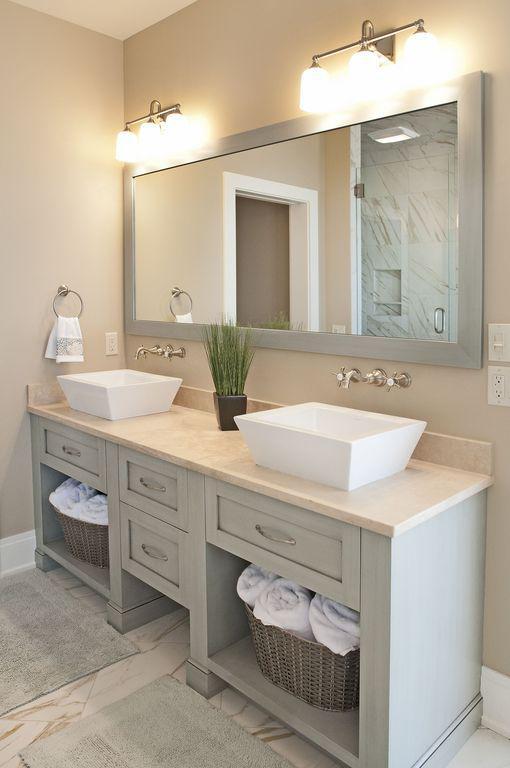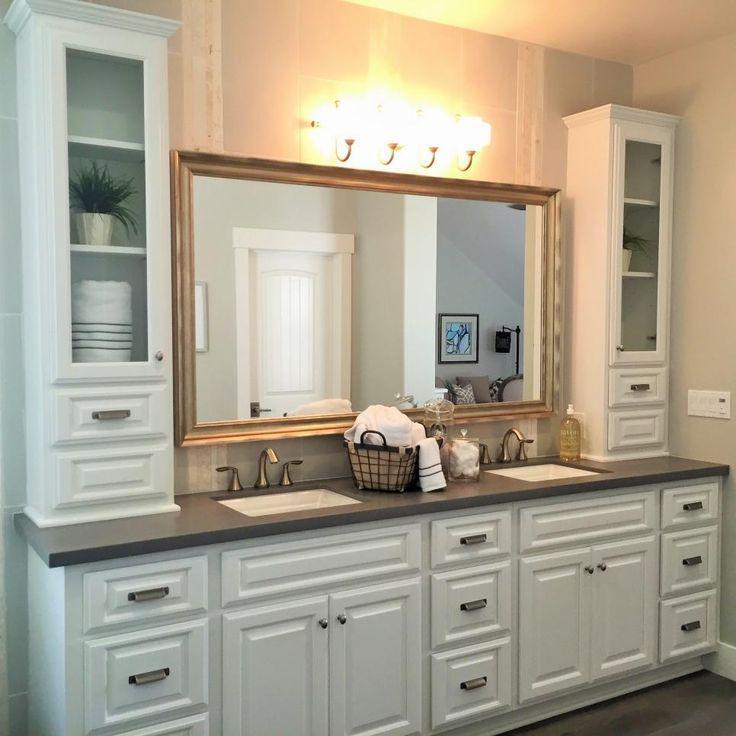The first image is the image on the left, the second image is the image on the right. Examine the images to the left and right. Is the description "A bathroom includes two oval shapes on the wall flanking a white cabinet, with lights above the ovals." accurate? Answer yes or no. No. The first image is the image on the left, the second image is the image on the right. Considering the images on both sides, is "The right image has two round mirrors on the wall above a bathroom sink." valid? Answer yes or no. No. The first image is the image on the left, the second image is the image on the right. For the images displayed, is the sentence "There is a single mirror over the counter in the image on the right." factually correct? Answer yes or no. Yes. 